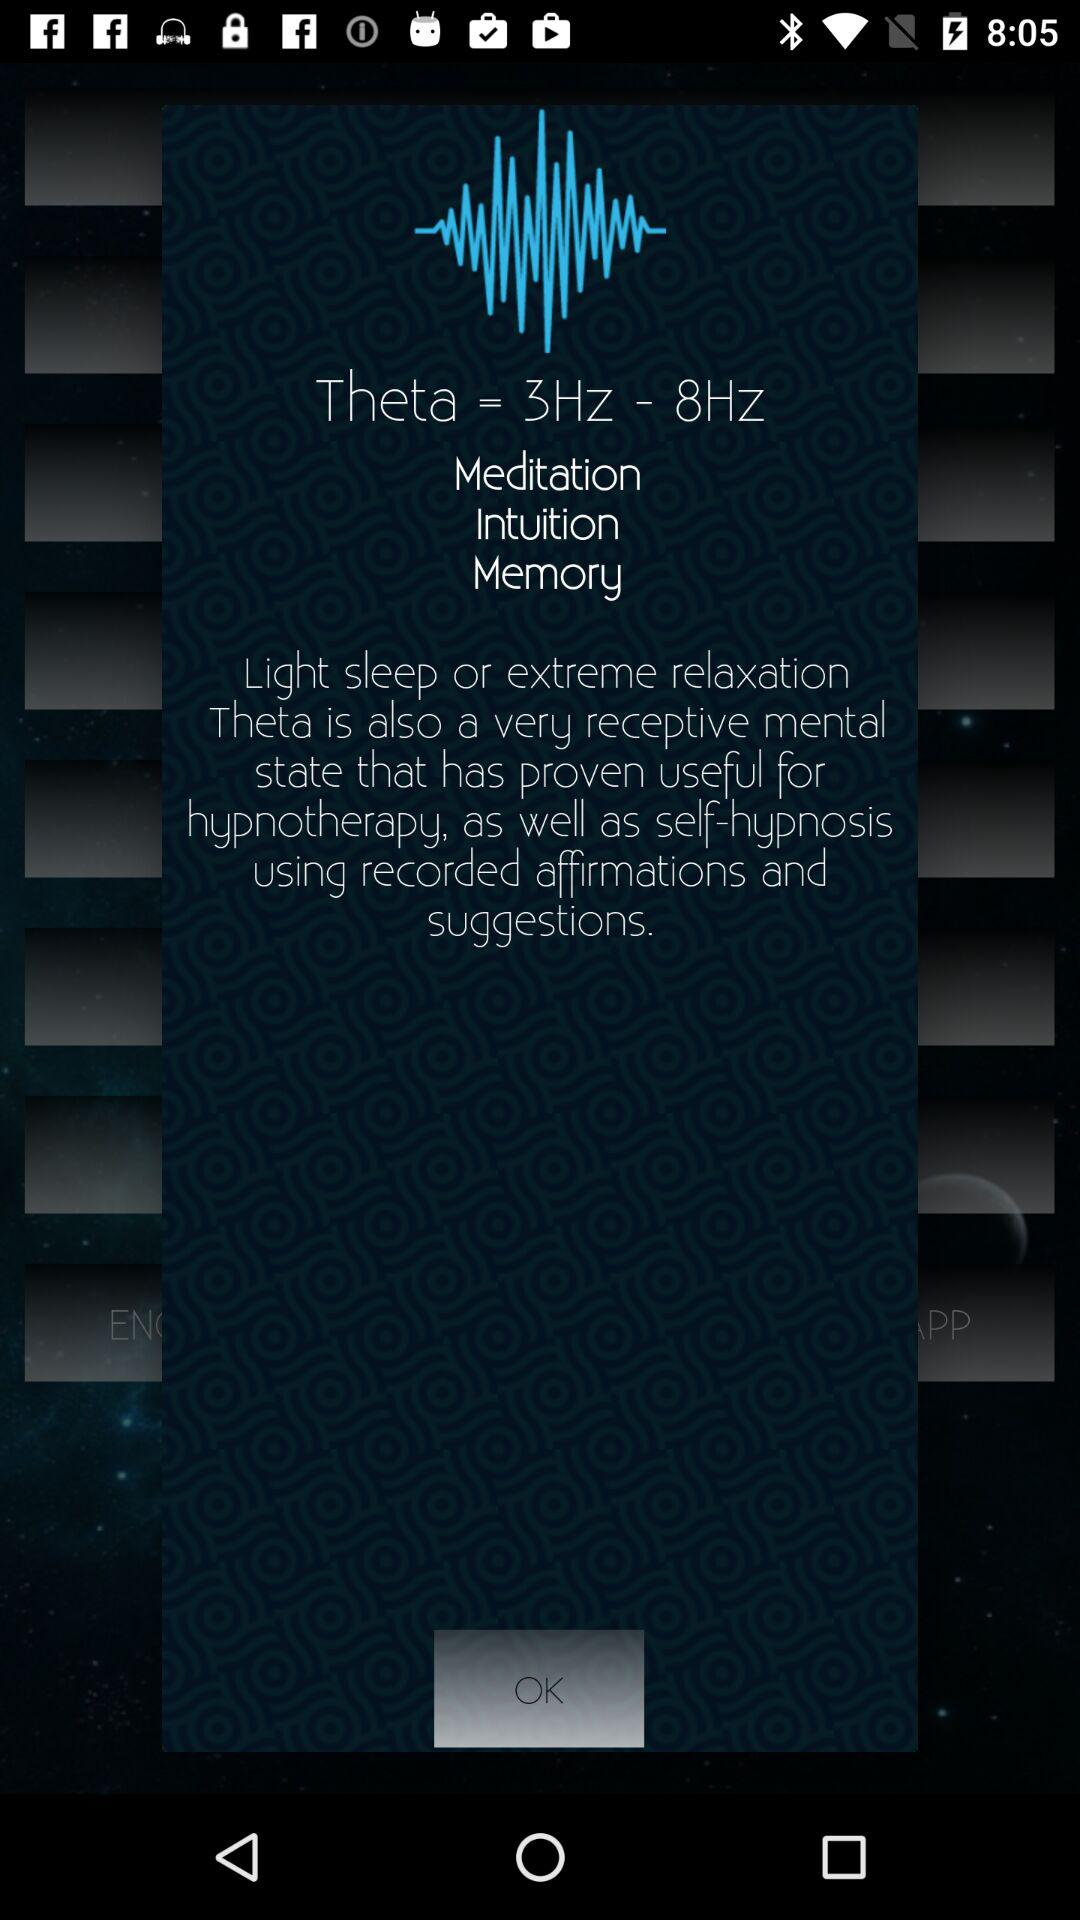What is the range of "Theta"? The range of "Theta" is from 3 Hz to 8 Hz. 